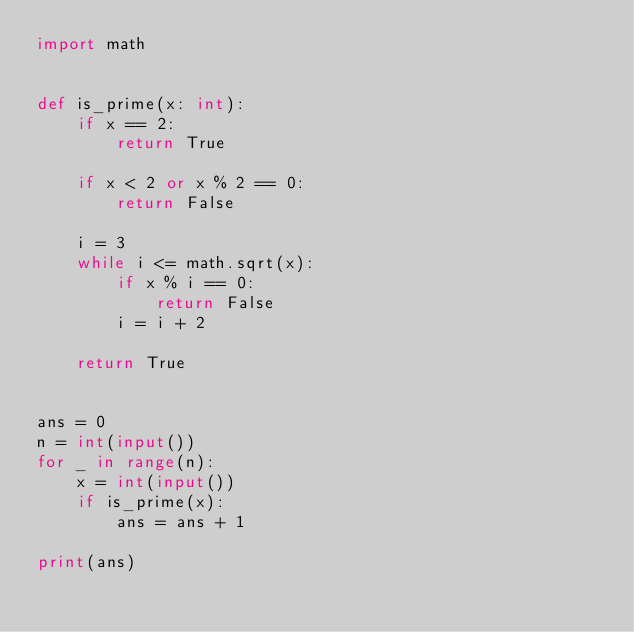Convert code to text. <code><loc_0><loc_0><loc_500><loc_500><_Python_>import math


def is_prime(x: int):
    if x == 2:
        return True

    if x < 2 or x % 2 == 0:
        return False

    i = 3
    while i <= math.sqrt(x):
        if x % i == 0:
            return False
        i = i + 2
        
    return True


ans = 0
n = int(input())
for _ in range(n):
    x = int(input())
    if is_prime(x):
        ans = ans + 1

print(ans)


</code> 